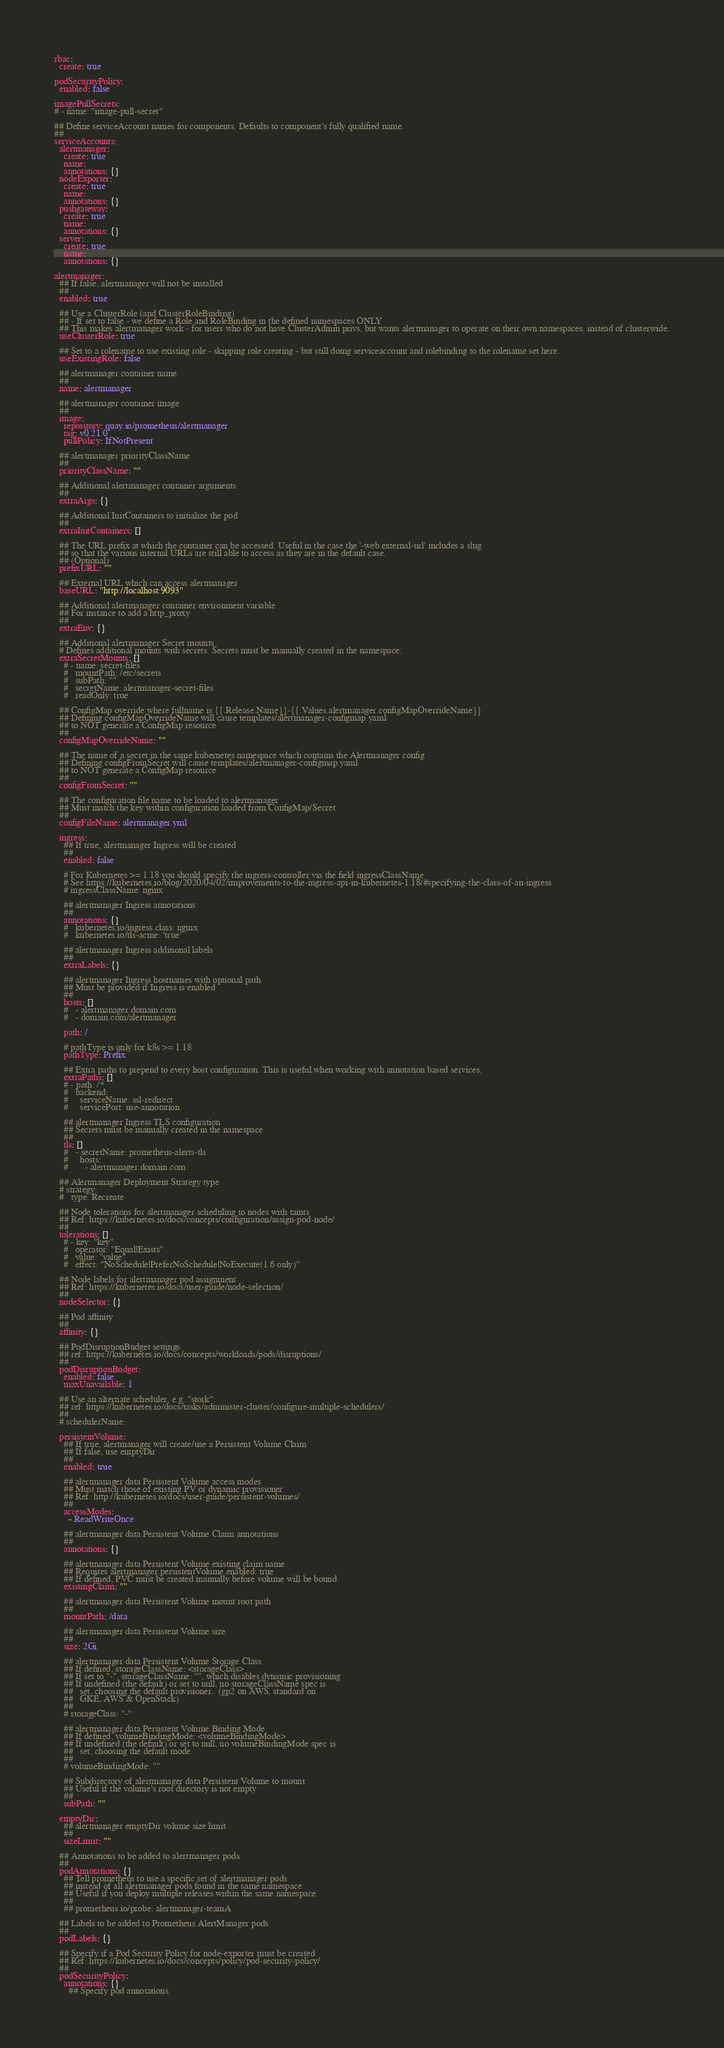<code> <loc_0><loc_0><loc_500><loc_500><_YAML_>rbac:
  create: true

podSecurityPolicy:
  enabled: false

imagePullSecrets:
# - name: "image-pull-secret"

## Define serviceAccount names for components. Defaults to component's fully qualified name.
##
serviceAccounts:
  alertmanager:
    create: true
    name:
    annotations: {}
  nodeExporter:
    create: true
    name:
    annotations: {}
  pushgateway:
    create: true
    name:
    annotations: {}
  server:
    create: true
    name:
    annotations: {}

alertmanager:
  ## If false, alertmanager will not be installed
  ##
  enabled: true

  ## Use a ClusterRole (and ClusterRoleBinding)
  ## - If set to false - we define a Role and RoleBinding in the defined namespaces ONLY
  ## This makes alertmanager work - for users who do not have ClusterAdmin privs, but wants alertmanager to operate on their own namespaces, instead of clusterwide.
  useClusterRole: true

  ## Set to a rolename to use existing role - skipping role creating - but still doing serviceaccount and rolebinding to the rolename set here.
  useExistingRole: false

  ## alertmanager container name
  ##
  name: alertmanager

  ## alertmanager container image
  ##
  image:
    repository: quay.io/prometheus/alertmanager
    tag: v0.21.0
    pullPolicy: IfNotPresent

  ## alertmanager priorityClassName
  ##
  priorityClassName: ""

  ## Additional alertmanager container arguments
  ##
  extraArgs: {}

  ## Additional InitContainers to initialize the pod
  ##
  extraInitContainers: []

  ## The URL prefix at which the container can be accessed. Useful in the case the '-web.external-url' includes a slug
  ## so that the various internal URLs are still able to access as they are in the default case.
  ## (Optional)
  prefixURL: ""

  ## External URL which can access alertmanager
  baseURL: "http://localhost:9093"

  ## Additional alertmanager container environment variable
  ## For instance to add a http_proxy
  ##
  extraEnv: {}

  ## Additional alertmanager Secret mounts
  # Defines additional mounts with secrets. Secrets must be manually created in the namespace.
  extraSecretMounts: []
    # - name: secret-files
    #   mountPath: /etc/secrets
    #   subPath: ""
    #   secretName: alertmanager-secret-files
    #   readOnly: true

  ## ConfigMap override where fullname is {{.Release.Name}}-{{.Values.alertmanager.configMapOverrideName}}
  ## Defining configMapOverrideName will cause templates/alertmanager-configmap.yaml
  ## to NOT generate a ConfigMap resource
  ##
  configMapOverrideName: ""

  ## The name of a secret in the same kubernetes namespace which contains the Alertmanager config
  ## Defining configFromSecret will cause templates/alertmanager-configmap.yaml
  ## to NOT generate a ConfigMap resource
  ##
  configFromSecret: ""

  ## The configuration file name to be loaded to alertmanager
  ## Must match the key within configuration loaded from ConfigMap/Secret
  ##
  configFileName: alertmanager.yml

  ingress:
    ## If true, alertmanager Ingress will be created
    ##
    enabled: false

    # For Kubernetes >= 1.18 you should specify the ingress-controller via the field ingressClassName
    # See https://kubernetes.io/blog/2020/04/02/improvements-to-the-ingress-api-in-kubernetes-1.18/#specifying-the-class-of-an-ingress
    # ingressClassName: nginx

    ## alertmanager Ingress annotations
    ##
    annotations: {}
    #   kubernetes.io/ingress.class: nginx
    #   kubernetes.io/tls-acme: 'true'

    ## alertmanager Ingress additional labels
    ##
    extraLabels: {}

    ## alertmanager Ingress hostnames with optional path
    ## Must be provided if Ingress is enabled
    ##
    hosts: []
    #   - alertmanager.domain.com
    #   - domain.com/alertmanager

    path: /

    # pathType is only for k8s >= 1.18
    pathType: Prefix

    ## Extra paths to prepend to every host configuration. This is useful when working with annotation based services.
    extraPaths: []
    # - path: /*
    #   backend:
    #     serviceName: ssl-redirect
    #     servicePort: use-annotation

    ## alertmanager Ingress TLS configuration
    ## Secrets must be manually created in the namespace
    ##
    tls: []
    #   - secretName: prometheus-alerts-tls
    #     hosts:
    #       - alertmanager.domain.com

  ## Alertmanager Deployment Strategy type
  # strategy:
  #   type: Recreate

  ## Node tolerations for alertmanager scheduling to nodes with taints
  ## Ref: https://kubernetes.io/docs/concepts/configuration/assign-pod-node/
  ##
  tolerations: []
    # - key: "key"
    #   operator: "Equal|Exists"
    #   value: "value"
    #   effect: "NoSchedule|PreferNoSchedule|NoExecute(1.6 only)"

  ## Node labels for alertmanager pod assignment
  ## Ref: https://kubernetes.io/docs/user-guide/node-selection/
  ##
  nodeSelector: {}

  ## Pod affinity
  ##
  affinity: {}

  ## PodDisruptionBudget settings
  ## ref: https://kubernetes.io/docs/concepts/workloads/pods/disruptions/
  ##
  podDisruptionBudget:
    enabled: false
    maxUnavailable: 1

  ## Use an alternate scheduler, e.g. "stork".
  ## ref: https://kubernetes.io/docs/tasks/administer-cluster/configure-multiple-schedulers/
  ##
  # schedulerName:

  persistentVolume:
    ## If true, alertmanager will create/use a Persistent Volume Claim
    ## If false, use emptyDir
    ##
    enabled: true

    ## alertmanager data Persistent Volume access modes
    ## Must match those of existing PV or dynamic provisioner
    ## Ref: http://kubernetes.io/docs/user-guide/persistent-volumes/
    ##
    accessModes:
      - ReadWriteOnce

    ## alertmanager data Persistent Volume Claim annotations
    ##
    annotations: {}

    ## alertmanager data Persistent Volume existing claim name
    ## Requires alertmanager.persistentVolume.enabled: true
    ## If defined, PVC must be created manually before volume will be bound
    existingClaim: ""

    ## alertmanager data Persistent Volume mount root path
    ##
    mountPath: /data

    ## alertmanager data Persistent Volume size
    ##
    size: 2Gi

    ## alertmanager data Persistent Volume Storage Class
    ## If defined, storageClassName: <storageClass>
    ## If set to "-", storageClassName: "", which disables dynamic provisioning
    ## If undefined (the default) or set to null, no storageClassName spec is
    ##   set, choosing the default provisioner.  (gp2 on AWS, standard on
    ##   GKE, AWS & OpenStack)
    ##
    # storageClass: "-"

    ## alertmanager data Persistent Volume Binding Mode
    ## If defined, volumeBindingMode: <volumeBindingMode>
    ## If undefined (the default) or set to null, no volumeBindingMode spec is
    ##   set, choosing the default mode.
    ##
    # volumeBindingMode: ""

    ## Subdirectory of alertmanager data Persistent Volume to mount
    ## Useful if the volume's root directory is not empty
    ##
    subPath: ""

  emptyDir:
    ## alertmanager emptyDir volume size limit
    ##
    sizeLimit: ""

  ## Annotations to be added to alertmanager pods
  ##
  podAnnotations: {}
    ## Tell prometheus to use a specific set of alertmanager pods
    ## instead of all alertmanager pods found in the same namespace
    ## Useful if you deploy multiple releases within the same namespace
    ##
    ## prometheus.io/probe: alertmanager-teamA

  ## Labels to be added to Prometheus AlertManager pods
  ##
  podLabels: {}

  ## Specify if a Pod Security Policy for node-exporter must be created
  ## Ref: https://kubernetes.io/docs/concepts/policy/pod-security-policy/
  ##
  podSecurityPolicy:
    annotations: {}
      ## Specify pod annotations</code> 